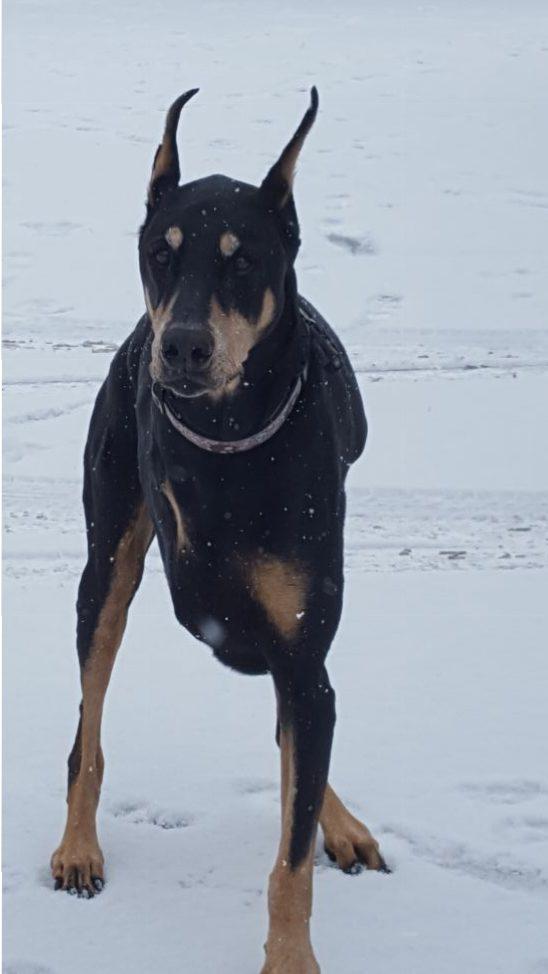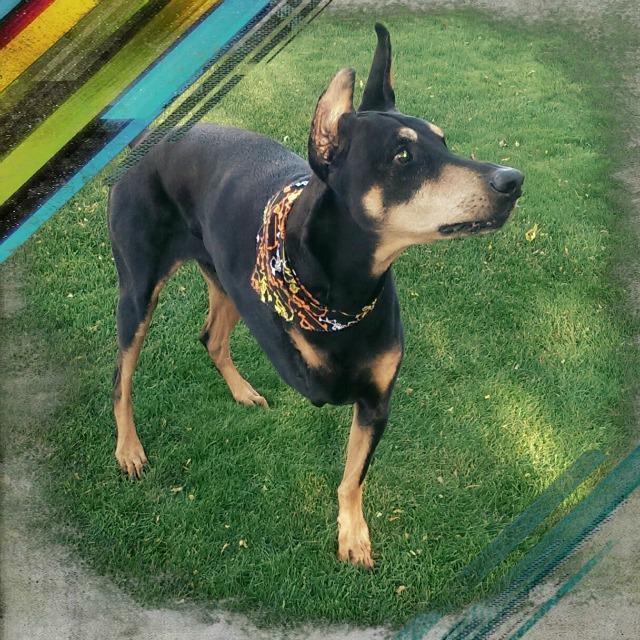The first image is the image on the left, the second image is the image on the right. Given the left and right images, does the statement "At least one of the dogs appears to be missing a back leg." hold true? Answer yes or no. No. The first image is the image on the left, the second image is the image on the right. Analyze the images presented: Is the assertion "Each image includes a black-and-tan dog that is standing upright and is missing one limb." valid? Answer yes or no. Yes. 